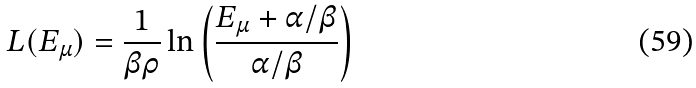<formula> <loc_0><loc_0><loc_500><loc_500>L ( E _ { \mu } ) = \frac { 1 } { \beta \rho } \ln \left ( \frac { E _ { \mu } + \alpha / \beta } { \alpha / \beta } \right )</formula> 